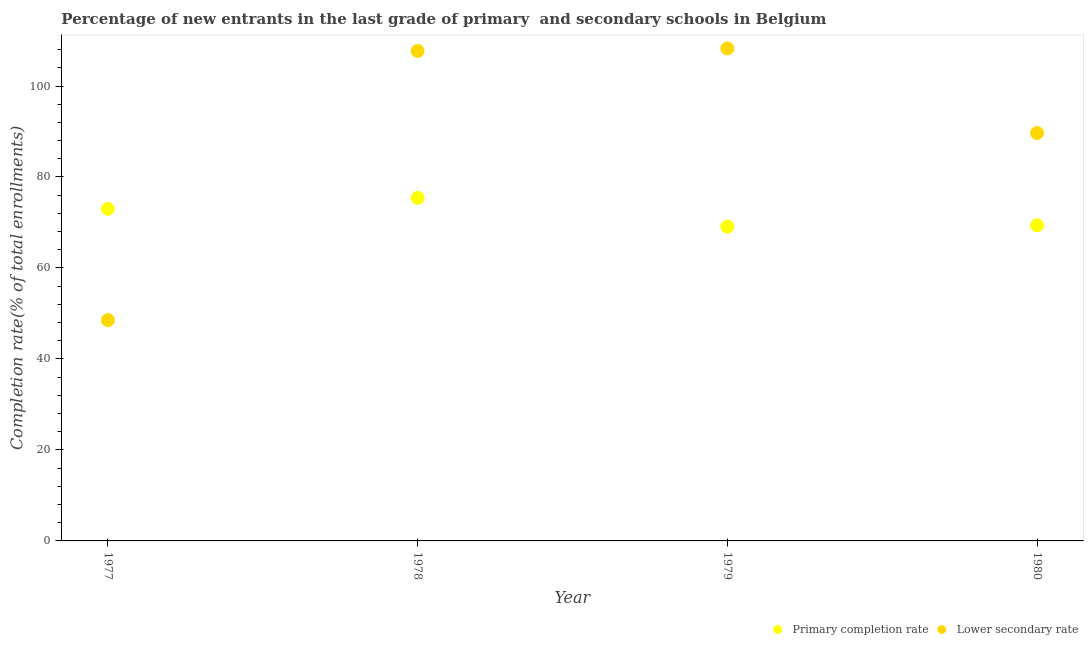How many different coloured dotlines are there?
Offer a very short reply. 2. Is the number of dotlines equal to the number of legend labels?
Give a very brief answer. Yes. What is the completion rate in secondary schools in 1977?
Your answer should be very brief. 48.55. Across all years, what is the maximum completion rate in primary schools?
Offer a terse response. 75.39. Across all years, what is the minimum completion rate in primary schools?
Provide a short and direct response. 69.08. In which year was the completion rate in secondary schools maximum?
Your response must be concise. 1979. In which year was the completion rate in primary schools minimum?
Provide a short and direct response. 1979. What is the total completion rate in primary schools in the graph?
Keep it short and to the point. 286.87. What is the difference between the completion rate in secondary schools in 1979 and that in 1980?
Offer a very short reply. 18.59. What is the difference between the completion rate in primary schools in 1979 and the completion rate in secondary schools in 1978?
Keep it short and to the point. -38.63. What is the average completion rate in secondary schools per year?
Offer a very short reply. 88.55. In the year 1979, what is the difference between the completion rate in primary schools and completion rate in secondary schools?
Your response must be concise. -39.17. What is the ratio of the completion rate in primary schools in 1978 to that in 1980?
Provide a short and direct response. 1.09. Is the completion rate in secondary schools in 1978 less than that in 1980?
Provide a succinct answer. No. Is the difference between the completion rate in secondary schools in 1979 and 1980 greater than the difference between the completion rate in primary schools in 1979 and 1980?
Provide a short and direct response. Yes. What is the difference between the highest and the second highest completion rate in secondary schools?
Keep it short and to the point. 0.55. What is the difference between the highest and the lowest completion rate in secondary schools?
Keep it short and to the point. 59.7. Is the completion rate in secondary schools strictly greater than the completion rate in primary schools over the years?
Ensure brevity in your answer.  No. How many dotlines are there?
Give a very brief answer. 2. What is the difference between two consecutive major ticks on the Y-axis?
Your answer should be very brief. 20. Does the graph contain any zero values?
Give a very brief answer. No. Does the graph contain grids?
Offer a very short reply. No. How are the legend labels stacked?
Your answer should be compact. Horizontal. What is the title of the graph?
Provide a short and direct response. Percentage of new entrants in the last grade of primary  and secondary schools in Belgium. What is the label or title of the Y-axis?
Offer a very short reply. Completion rate(% of total enrollments). What is the Completion rate(% of total enrollments) of Primary completion rate in 1977?
Your answer should be very brief. 73.01. What is the Completion rate(% of total enrollments) in Lower secondary rate in 1977?
Offer a very short reply. 48.55. What is the Completion rate(% of total enrollments) in Primary completion rate in 1978?
Your response must be concise. 75.39. What is the Completion rate(% of total enrollments) in Lower secondary rate in 1978?
Give a very brief answer. 107.71. What is the Completion rate(% of total enrollments) in Primary completion rate in 1979?
Keep it short and to the point. 69.08. What is the Completion rate(% of total enrollments) in Lower secondary rate in 1979?
Your answer should be very brief. 108.26. What is the Completion rate(% of total enrollments) of Primary completion rate in 1980?
Provide a succinct answer. 69.38. What is the Completion rate(% of total enrollments) in Lower secondary rate in 1980?
Offer a very short reply. 89.67. Across all years, what is the maximum Completion rate(% of total enrollments) in Primary completion rate?
Your answer should be compact. 75.39. Across all years, what is the maximum Completion rate(% of total enrollments) in Lower secondary rate?
Offer a terse response. 108.26. Across all years, what is the minimum Completion rate(% of total enrollments) of Primary completion rate?
Give a very brief answer. 69.08. Across all years, what is the minimum Completion rate(% of total enrollments) of Lower secondary rate?
Ensure brevity in your answer.  48.55. What is the total Completion rate(% of total enrollments) of Primary completion rate in the graph?
Provide a succinct answer. 286.87. What is the total Completion rate(% of total enrollments) in Lower secondary rate in the graph?
Give a very brief answer. 354.19. What is the difference between the Completion rate(% of total enrollments) in Primary completion rate in 1977 and that in 1978?
Provide a short and direct response. -2.38. What is the difference between the Completion rate(% of total enrollments) of Lower secondary rate in 1977 and that in 1978?
Provide a short and direct response. -59.16. What is the difference between the Completion rate(% of total enrollments) of Primary completion rate in 1977 and that in 1979?
Keep it short and to the point. 3.93. What is the difference between the Completion rate(% of total enrollments) in Lower secondary rate in 1977 and that in 1979?
Offer a very short reply. -59.7. What is the difference between the Completion rate(% of total enrollments) in Primary completion rate in 1977 and that in 1980?
Make the answer very short. 3.63. What is the difference between the Completion rate(% of total enrollments) of Lower secondary rate in 1977 and that in 1980?
Give a very brief answer. -41.11. What is the difference between the Completion rate(% of total enrollments) in Primary completion rate in 1978 and that in 1979?
Offer a terse response. 6.31. What is the difference between the Completion rate(% of total enrollments) of Lower secondary rate in 1978 and that in 1979?
Offer a terse response. -0.55. What is the difference between the Completion rate(% of total enrollments) of Primary completion rate in 1978 and that in 1980?
Offer a very short reply. 6.02. What is the difference between the Completion rate(% of total enrollments) in Lower secondary rate in 1978 and that in 1980?
Offer a very short reply. 18.04. What is the difference between the Completion rate(% of total enrollments) in Primary completion rate in 1979 and that in 1980?
Make the answer very short. -0.3. What is the difference between the Completion rate(% of total enrollments) of Lower secondary rate in 1979 and that in 1980?
Ensure brevity in your answer.  18.59. What is the difference between the Completion rate(% of total enrollments) in Primary completion rate in 1977 and the Completion rate(% of total enrollments) in Lower secondary rate in 1978?
Provide a succinct answer. -34.7. What is the difference between the Completion rate(% of total enrollments) in Primary completion rate in 1977 and the Completion rate(% of total enrollments) in Lower secondary rate in 1979?
Your answer should be very brief. -35.25. What is the difference between the Completion rate(% of total enrollments) of Primary completion rate in 1977 and the Completion rate(% of total enrollments) of Lower secondary rate in 1980?
Keep it short and to the point. -16.66. What is the difference between the Completion rate(% of total enrollments) of Primary completion rate in 1978 and the Completion rate(% of total enrollments) of Lower secondary rate in 1979?
Provide a short and direct response. -32.86. What is the difference between the Completion rate(% of total enrollments) in Primary completion rate in 1978 and the Completion rate(% of total enrollments) in Lower secondary rate in 1980?
Your answer should be very brief. -14.27. What is the difference between the Completion rate(% of total enrollments) of Primary completion rate in 1979 and the Completion rate(% of total enrollments) of Lower secondary rate in 1980?
Offer a terse response. -20.58. What is the average Completion rate(% of total enrollments) of Primary completion rate per year?
Offer a terse response. 71.72. What is the average Completion rate(% of total enrollments) in Lower secondary rate per year?
Make the answer very short. 88.55. In the year 1977, what is the difference between the Completion rate(% of total enrollments) of Primary completion rate and Completion rate(% of total enrollments) of Lower secondary rate?
Your answer should be very brief. 24.46. In the year 1978, what is the difference between the Completion rate(% of total enrollments) of Primary completion rate and Completion rate(% of total enrollments) of Lower secondary rate?
Make the answer very short. -32.32. In the year 1979, what is the difference between the Completion rate(% of total enrollments) of Primary completion rate and Completion rate(% of total enrollments) of Lower secondary rate?
Give a very brief answer. -39.17. In the year 1980, what is the difference between the Completion rate(% of total enrollments) of Primary completion rate and Completion rate(% of total enrollments) of Lower secondary rate?
Ensure brevity in your answer.  -20.29. What is the ratio of the Completion rate(% of total enrollments) of Primary completion rate in 1977 to that in 1978?
Your response must be concise. 0.97. What is the ratio of the Completion rate(% of total enrollments) in Lower secondary rate in 1977 to that in 1978?
Make the answer very short. 0.45. What is the ratio of the Completion rate(% of total enrollments) of Primary completion rate in 1977 to that in 1979?
Make the answer very short. 1.06. What is the ratio of the Completion rate(% of total enrollments) in Lower secondary rate in 1977 to that in 1979?
Your answer should be compact. 0.45. What is the ratio of the Completion rate(% of total enrollments) in Primary completion rate in 1977 to that in 1980?
Offer a terse response. 1.05. What is the ratio of the Completion rate(% of total enrollments) of Lower secondary rate in 1977 to that in 1980?
Your answer should be very brief. 0.54. What is the ratio of the Completion rate(% of total enrollments) of Primary completion rate in 1978 to that in 1979?
Provide a succinct answer. 1.09. What is the ratio of the Completion rate(% of total enrollments) of Primary completion rate in 1978 to that in 1980?
Provide a succinct answer. 1.09. What is the ratio of the Completion rate(% of total enrollments) in Lower secondary rate in 1978 to that in 1980?
Provide a short and direct response. 1.2. What is the ratio of the Completion rate(% of total enrollments) of Primary completion rate in 1979 to that in 1980?
Your response must be concise. 1. What is the ratio of the Completion rate(% of total enrollments) in Lower secondary rate in 1979 to that in 1980?
Ensure brevity in your answer.  1.21. What is the difference between the highest and the second highest Completion rate(% of total enrollments) of Primary completion rate?
Your answer should be very brief. 2.38. What is the difference between the highest and the second highest Completion rate(% of total enrollments) of Lower secondary rate?
Your answer should be compact. 0.55. What is the difference between the highest and the lowest Completion rate(% of total enrollments) of Primary completion rate?
Offer a terse response. 6.31. What is the difference between the highest and the lowest Completion rate(% of total enrollments) in Lower secondary rate?
Provide a short and direct response. 59.7. 